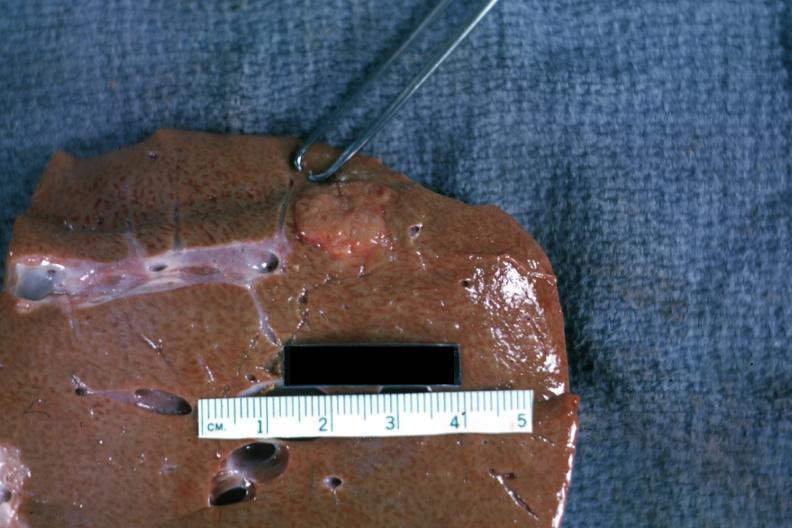what is present?
Answer the question using a single word or phrase. Hepatobiliary 